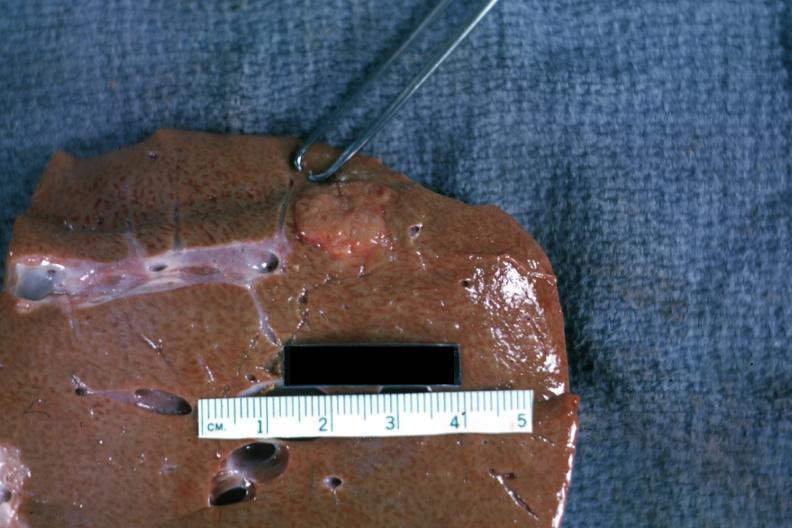what is present?
Answer the question using a single word or phrase. Hepatobiliary 